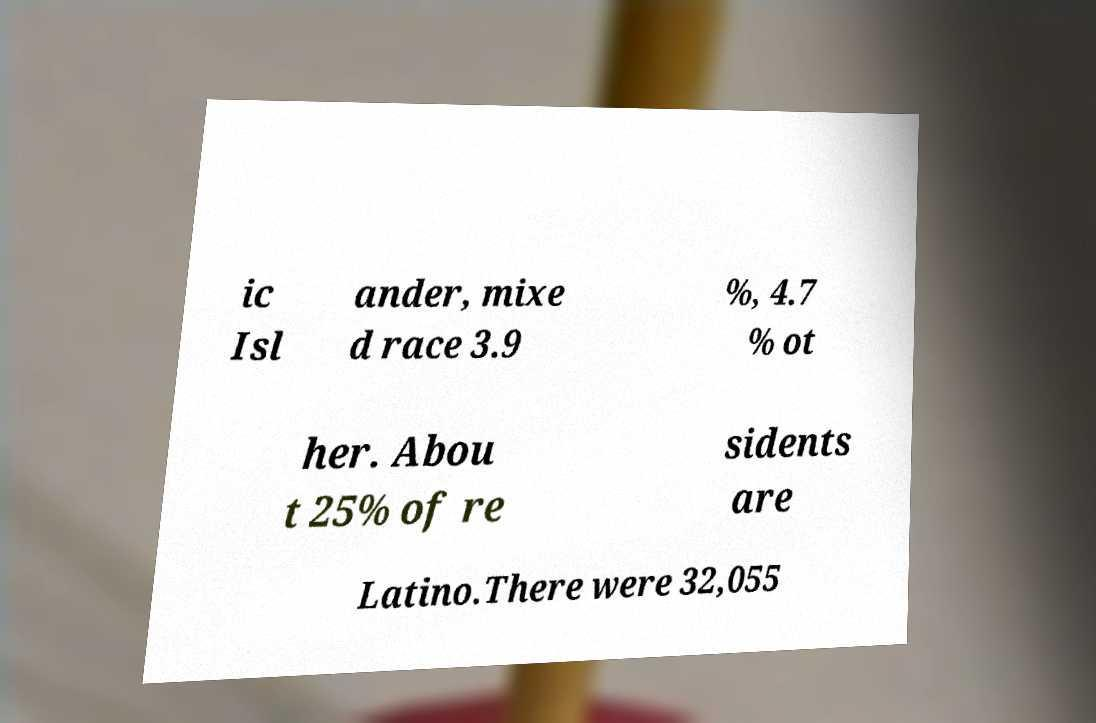Please read and relay the text visible in this image. What does it say? ic Isl ander, mixe d race 3.9 %, 4.7 % ot her. Abou t 25% of re sidents are Latino.There were 32,055 